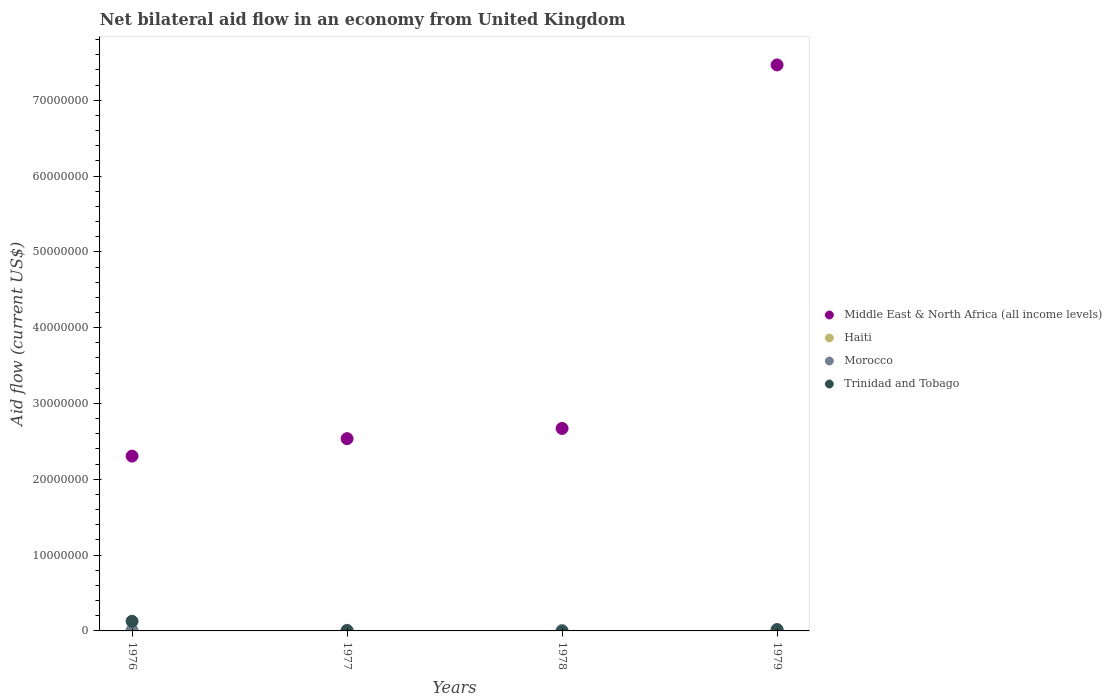How many different coloured dotlines are there?
Provide a short and direct response. 4. Is the number of dotlines equal to the number of legend labels?
Keep it short and to the point. No. What is the net bilateral aid flow in Middle East & North Africa (all income levels) in 1979?
Keep it short and to the point. 7.47e+07. Across all years, what is the maximum net bilateral aid flow in Trinidad and Tobago?
Offer a terse response. 1.27e+06. Across all years, what is the minimum net bilateral aid flow in Morocco?
Offer a very short reply. 6.00e+04. In which year was the net bilateral aid flow in Morocco maximum?
Your response must be concise. 1977. What is the total net bilateral aid flow in Middle East & North Africa (all income levels) in the graph?
Your answer should be very brief. 1.50e+08. What is the difference between the net bilateral aid flow in Middle East & North Africa (all income levels) in 1976 and that in 1979?
Offer a very short reply. -5.16e+07. What is the average net bilateral aid flow in Middle East & North Africa (all income levels) per year?
Your answer should be very brief. 3.74e+07. What is the ratio of the net bilateral aid flow in Morocco in 1976 to that in 1977?
Your answer should be compact. 0.75. Is the net bilateral aid flow in Trinidad and Tobago in 1976 less than that in 1977?
Your answer should be compact. No. Is the difference between the net bilateral aid flow in Morocco in 1977 and 1978 greater than the difference between the net bilateral aid flow in Haiti in 1977 and 1978?
Offer a very short reply. No. What is the difference between the highest and the second highest net bilateral aid flow in Middle East & North Africa (all income levels)?
Your answer should be compact. 4.80e+07. What is the difference between the highest and the lowest net bilateral aid flow in Trinidad and Tobago?
Provide a succinct answer. 1.27e+06. In how many years, is the net bilateral aid flow in Morocco greater than the average net bilateral aid flow in Morocco taken over all years?
Ensure brevity in your answer.  2. Is the sum of the net bilateral aid flow in Haiti in 1978 and 1979 greater than the maximum net bilateral aid flow in Morocco across all years?
Offer a very short reply. No. Is it the case that in every year, the sum of the net bilateral aid flow in Morocco and net bilateral aid flow in Haiti  is greater than the net bilateral aid flow in Middle East & North Africa (all income levels)?
Ensure brevity in your answer.  No. Is the net bilateral aid flow in Morocco strictly less than the net bilateral aid flow in Haiti over the years?
Your answer should be compact. No. How many years are there in the graph?
Offer a terse response. 4. What is the difference between two consecutive major ticks on the Y-axis?
Make the answer very short. 1.00e+07. Are the values on the major ticks of Y-axis written in scientific E-notation?
Provide a short and direct response. No. Does the graph contain any zero values?
Provide a succinct answer. Yes. How many legend labels are there?
Give a very brief answer. 4. How are the legend labels stacked?
Provide a short and direct response. Vertical. What is the title of the graph?
Ensure brevity in your answer.  Net bilateral aid flow in an economy from United Kingdom. What is the Aid flow (current US$) of Middle East & North Africa (all income levels) in 1976?
Ensure brevity in your answer.  2.31e+07. What is the Aid flow (current US$) in Morocco in 1976?
Offer a very short reply. 6.00e+04. What is the Aid flow (current US$) of Trinidad and Tobago in 1976?
Make the answer very short. 1.27e+06. What is the Aid flow (current US$) of Middle East & North Africa (all income levels) in 1977?
Ensure brevity in your answer.  2.54e+07. What is the Aid flow (current US$) of Haiti in 1977?
Give a very brief answer. 3.00e+04. What is the Aid flow (current US$) of Middle East & North Africa (all income levels) in 1978?
Offer a terse response. 2.67e+07. What is the Aid flow (current US$) of Haiti in 1978?
Ensure brevity in your answer.  10000. What is the Aid flow (current US$) in Middle East & North Africa (all income levels) in 1979?
Make the answer very short. 7.47e+07. What is the Aid flow (current US$) of Haiti in 1979?
Provide a succinct answer. 10000. What is the Aid flow (current US$) of Morocco in 1979?
Ensure brevity in your answer.  7.00e+04. What is the Aid flow (current US$) in Trinidad and Tobago in 1979?
Provide a succinct answer. 1.80e+05. Across all years, what is the maximum Aid flow (current US$) in Middle East & North Africa (all income levels)?
Provide a short and direct response. 7.47e+07. Across all years, what is the maximum Aid flow (current US$) in Trinidad and Tobago?
Provide a short and direct response. 1.27e+06. Across all years, what is the minimum Aid flow (current US$) in Middle East & North Africa (all income levels)?
Ensure brevity in your answer.  2.31e+07. Across all years, what is the minimum Aid flow (current US$) of Trinidad and Tobago?
Ensure brevity in your answer.  0. What is the total Aid flow (current US$) of Middle East & North Africa (all income levels) in the graph?
Make the answer very short. 1.50e+08. What is the total Aid flow (current US$) of Morocco in the graph?
Provide a succinct answer. 2.70e+05. What is the total Aid flow (current US$) of Trinidad and Tobago in the graph?
Ensure brevity in your answer.  1.47e+06. What is the difference between the Aid flow (current US$) in Middle East & North Africa (all income levels) in 1976 and that in 1977?
Offer a terse response. -2.30e+06. What is the difference between the Aid flow (current US$) in Trinidad and Tobago in 1976 and that in 1977?
Your answer should be very brief. 1.25e+06. What is the difference between the Aid flow (current US$) in Middle East & North Africa (all income levels) in 1976 and that in 1978?
Provide a short and direct response. -3.65e+06. What is the difference between the Aid flow (current US$) of Morocco in 1976 and that in 1978?
Offer a very short reply. 0. What is the difference between the Aid flow (current US$) of Middle East & North Africa (all income levels) in 1976 and that in 1979?
Give a very brief answer. -5.16e+07. What is the difference between the Aid flow (current US$) in Trinidad and Tobago in 1976 and that in 1979?
Keep it short and to the point. 1.09e+06. What is the difference between the Aid flow (current US$) of Middle East & North Africa (all income levels) in 1977 and that in 1978?
Offer a terse response. -1.35e+06. What is the difference between the Aid flow (current US$) of Haiti in 1977 and that in 1978?
Ensure brevity in your answer.  2.00e+04. What is the difference between the Aid flow (current US$) in Middle East & North Africa (all income levels) in 1977 and that in 1979?
Offer a terse response. -4.93e+07. What is the difference between the Aid flow (current US$) of Trinidad and Tobago in 1977 and that in 1979?
Your answer should be very brief. -1.60e+05. What is the difference between the Aid flow (current US$) in Middle East & North Africa (all income levels) in 1978 and that in 1979?
Keep it short and to the point. -4.80e+07. What is the difference between the Aid flow (current US$) in Middle East & North Africa (all income levels) in 1976 and the Aid flow (current US$) in Haiti in 1977?
Keep it short and to the point. 2.30e+07. What is the difference between the Aid flow (current US$) of Middle East & North Africa (all income levels) in 1976 and the Aid flow (current US$) of Morocco in 1977?
Offer a terse response. 2.30e+07. What is the difference between the Aid flow (current US$) in Middle East & North Africa (all income levels) in 1976 and the Aid flow (current US$) in Trinidad and Tobago in 1977?
Offer a very short reply. 2.30e+07. What is the difference between the Aid flow (current US$) in Haiti in 1976 and the Aid flow (current US$) in Morocco in 1977?
Offer a terse response. -10000. What is the difference between the Aid flow (current US$) in Middle East & North Africa (all income levels) in 1976 and the Aid flow (current US$) in Haiti in 1978?
Provide a succinct answer. 2.30e+07. What is the difference between the Aid flow (current US$) in Middle East & North Africa (all income levels) in 1976 and the Aid flow (current US$) in Morocco in 1978?
Ensure brevity in your answer.  2.30e+07. What is the difference between the Aid flow (current US$) of Haiti in 1976 and the Aid flow (current US$) of Morocco in 1978?
Your response must be concise. 10000. What is the difference between the Aid flow (current US$) in Middle East & North Africa (all income levels) in 1976 and the Aid flow (current US$) in Haiti in 1979?
Give a very brief answer. 2.30e+07. What is the difference between the Aid flow (current US$) of Middle East & North Africa (all income levels) in 1976 and the Aid flow (current US$) of Morocco in 1979?
Offer a very short reply. 2.30e+07. What is the difference between the Aid flow (current US$) in Middle East & North Africa (all income levels) in 1976 and the Aid flow (current US$) in Trinidad and Tobago in 1979?
Keep it short and to the point. 2.29e+07. What is the difference between the Aid flow (current US$) of Morocco in 1976 and the Aid flow (current US$) of Trinidad and Tobago in 1979?
Make the answer very short. -1.20e+05. What is the difference between the Aid flow (current US$) of Middle East & North Africa (all income levels) in 1977 and the Aid flow (current US$) of Haiti in 1978?
Ensure brevity in your answer.  2.54e+07. What is the difference between the Aid flow (current US$) of Middle East & North Africa (all income levels) in 1977 and the Aid flow (current US$) of Morocco in 1978?
Provide a short and direct response. 2.53e+07. What is the difference between the Aid flow (current US$) in Middle East & North Africa (all income levels) in 1977 and the Aid flow (current US$) in Haiti in 1979?
Provide a short and direct response. 2.54e+07. What is the difference between the Aid flow (current US$) of Middle East & North Africa (all income levels) in 1977 and the Aid flow (current US$) of Morocco in 1979?
Give a very brief answer. 2.53e+07. What is the difference between the Aid flow (current US$) of Middle East & North Africa (all income levels) in 1977 and the Aid flow (current US$) of Trinidad and Tobago in 1979?
Provide a short and direct response. 2.52e+07. What is the difference between the Aid flow (current US$) in Haiti in 1977 and the Aid flow (current US$) in Trinidad and Tobago in 1979?
Make the answer very short. -1.50e+05. What is the difference between the Aid flow (current US$) of Middle East & North Africa (all income levels) in 1978 and the Aid flow (current US$) of Haiti in 1979?
Ensure brevity in your answer.  2.67e+07. What is the difference between the Aid flow (current US$) of Middle East & North Africa (all income levels) in 1978 and the Aid flow (current US$) of Morocco in 1979?
Your response must be concise. 2.66e+07. What is the difference between the Aid flow (current US$) of Middle East & North Africa (all income levels) in 1978 and the Aid flow (current US$) of Trinidad and Tobago in 1979?
Ensure brevity in your answer.  2.65e+07. What is the difference between the Aid flow (current US$) in Haiti in 1978 and the Aid flow (current US$) in Morocco in 1979?
Offer a very short reply. -6.00e+04. What is the difference between the Aid flow (current US$) of Morocco in 1978 and the Aid flow (current US$) of Trinidad and Tobago in 1979?
Your answer should be very brief. -1.20e+05. What is the average Aid flow (current US$) in Middle East & North Africa (all income levels) per year?
Offer a terse response. 3.74e+07. What is the average Aid flow (current US$) of Morocco per year?
Your answer should be very brief. 6.75e+04. What is the average Aid flow (current US$) in Trinidad and Tobago per year?
Give a very brief answer. 3.68e+05. In the year 1976, what is the difference between the Aid flow (current US$) in Middle East & North Africa (all income levels) and Aid flow (current US$) in Haiti?
Make the answer very short. 2.30e+07. In the year 1976, what is the difference between the Aid flow (current US$) of Middle East & North Africa (all income levels) and Aid flow (current US$) of Morocco?
Your answer should be compact. 2.30e+07. In the year 1976, what is the difference between the Aid flow (current US$) in Middle East & North Africa (all income levels) and Aid flow (current US$) in Trinidad and Tobago?
Your answer should be very brief. 2.18e+07. In the year 1976, what is the difference between the Aid flow (current US$) of Haiti and Aid flow (current US$) of Morocco?
Ensure brevity in your answer.  10000. In the year 1976, what is the difference between the Aid flow (current US$) of Haiti and Aid flow (current US$) of Trinidad and Tobago?
Provide a succinct answer. -1.20e+06. In the year 1976, what is the difference between the Aid flow (current US$) in Morocco and Aid flow (current US$) in Trinidad and Tobago?
Ensure brevity in your answer.  -1.21e+06. In the year 1977, what is the difference between the Aid flow (current US$) in Middle East & North Africa (all income levels) and Aid flow (current US$) in Haiti?
Make the answer very short. 2.53e+07. In the year 1977, what is the difference between the Aid flow (current US$) in Middle East & North Africa (all income levels) and Aid flow (current US$) in Morocco?
Make the answer very short. 2.53e+07. In the year 1977, what is the difference between the Aid flow (current US$) of Middle East & North Africa (all income levels) and Aid flow (current US$) of Trinidad and Tobago?
Make the answer very short. 2.53e+07. In the year 1977, what is the difference between the Aid flow (current US$) of Haiti and Aid flow (current US$) of Morocco?
Provide a succinct answer. -5.00e+04. In the year 1977, what is the difference between the Aid flow (current US$) in Morocco and Aid flow (current US$) in Trinidad and Tobago?
Keep it short and to the point. 6.00e+04. In the year 1978, what is the difference between the Aid flow (current US$) in Middle East & North Africa (all income levels) and Aid flow (current US$) in Haiti?
Make the answer very short. 2.67e+07. In the year 1978, what is the difference between the Aid flow (current US$) in Middle East & North Africa (all income levels) and Aid flow (current US$) in Morocco?
Your answer should be very brief. 2.66e+07. In the year 1979, what is the difference between the Aid flow (current US$) of Middle East & North Africa (all income levels) and Aid flow (current US$) of Haiti?
Your answer should be very brief. 7.46e+07. In the year 1979, what is the difference between the Aid flow (current US$) of Middle East & North Africa (all income levels) and Aid flow (current US$) of Morocco?
Make the answer very short. 7.46e+07. In the year 1979, what is the difference between the Aid flow (current US$) in Middle East & North Africa (all income levels) and Aid flow (current US$) in Trinidad and Tobago?
Provide a short and direct response. 7.45e+07. In the year 1979, what is the difference between the Aid flow (current US$) of Morocco and Aid flow (current US$) of Trinidad and Tobago?
Offer a terse response. -1.10e+05. What is the ratio of the Aid flow (current US$) of Middle East & North Africa (all income levels) in 1976 to that in 1977?
Your answer should be compact. 0.91. What is the ratio of the Aid flow (current US$) of Haiti in 1976 to that in 1977?
Make the answer very short. 2.33. What is the ratio of the Aid flow (current US$) in Trinidad and Tobago in 1976 to that in 1977?
Your response must be concise. 63.5. What is the ratio of the Aid flow (current US$) in Middle East & North Africa (all income levels) in 1976 to that in 1978?
Provide a short and direct response. 0.86. What is the ratio of the Aid flow (current US$) of Haiti in 1976 to that in 1978?
Provide a succinct answer. 7. What is the ratio of the Aid flow (current US$) in Middle East & North Africa (all income levels) in 1976 to that in 1979?
Offer a very short reply. 0.31. What is the ratio of the Aid flow (current US$) in Haiti in 1976 to that in 1979?
Offer a terse response. 7. What is the ratio of the Aid flow (current US$) of Trinidad and Tobago in 1976 to that in 1979?
Make the answer very short. 7.06. What is the ratio of the Aid flow (current US$) of Middle East & North Africa (all income levels) in 1977 to that in 1978?
Your answer should be compact. 0.95. What is the ratio of the Aid flow (current US$) of Middle East & North Africa (all income levels) in 1977 to that in 1979?
Your answer should be compact. 0.34. What is the ratio of the Aid flow (current US$) in Haiti in 1977 to that in 1979?
Your answer should be very brief. 3. What is the ratio of the Aid flow (current US$) of Middle East & North Africa (all income levels) in 1978 to that in 1979?
Ensure brevity in your answer.  0.36. What is the ratio of the Aid flow (current US$) in Haiti in 1978 to that in 1979?
Give a very brief answer. 1. What is the ratio of the Aid flow (current US$) of Morocco in 1978 to that in 1979?
Provide a succinct answer. 0.86. What is the difference between the highest and the second highest Aid flow (current US$) of Middle East & North Africa (all income levels)?
Provide a short and direct response. 4.80e+07. What is the difference between the highest and the second highest Aid flow (current US$) in Trinidad and Tobago?
Your response must be concise. 1.09e+06. What is the difference between the highest and the lowest Aid flow (current US$) of Middle East & North Africa (all income levels)?
Provide a short and direct response. 5.16e+07. What is the difference between the highest and the lowest Aid flow (current US$) in Haiti?
Provide a short and direct response. 6.00e+04. What is the difference between the highest and the lowest Aid flow (current US$) in Morocco?
Offer a terse response. 2.00e+04. What is the difference between the highest and the lowest Aid flow (current US$) in Trinidad and Tobago?
Ensure brevity in your answer.  1.27e+06. 